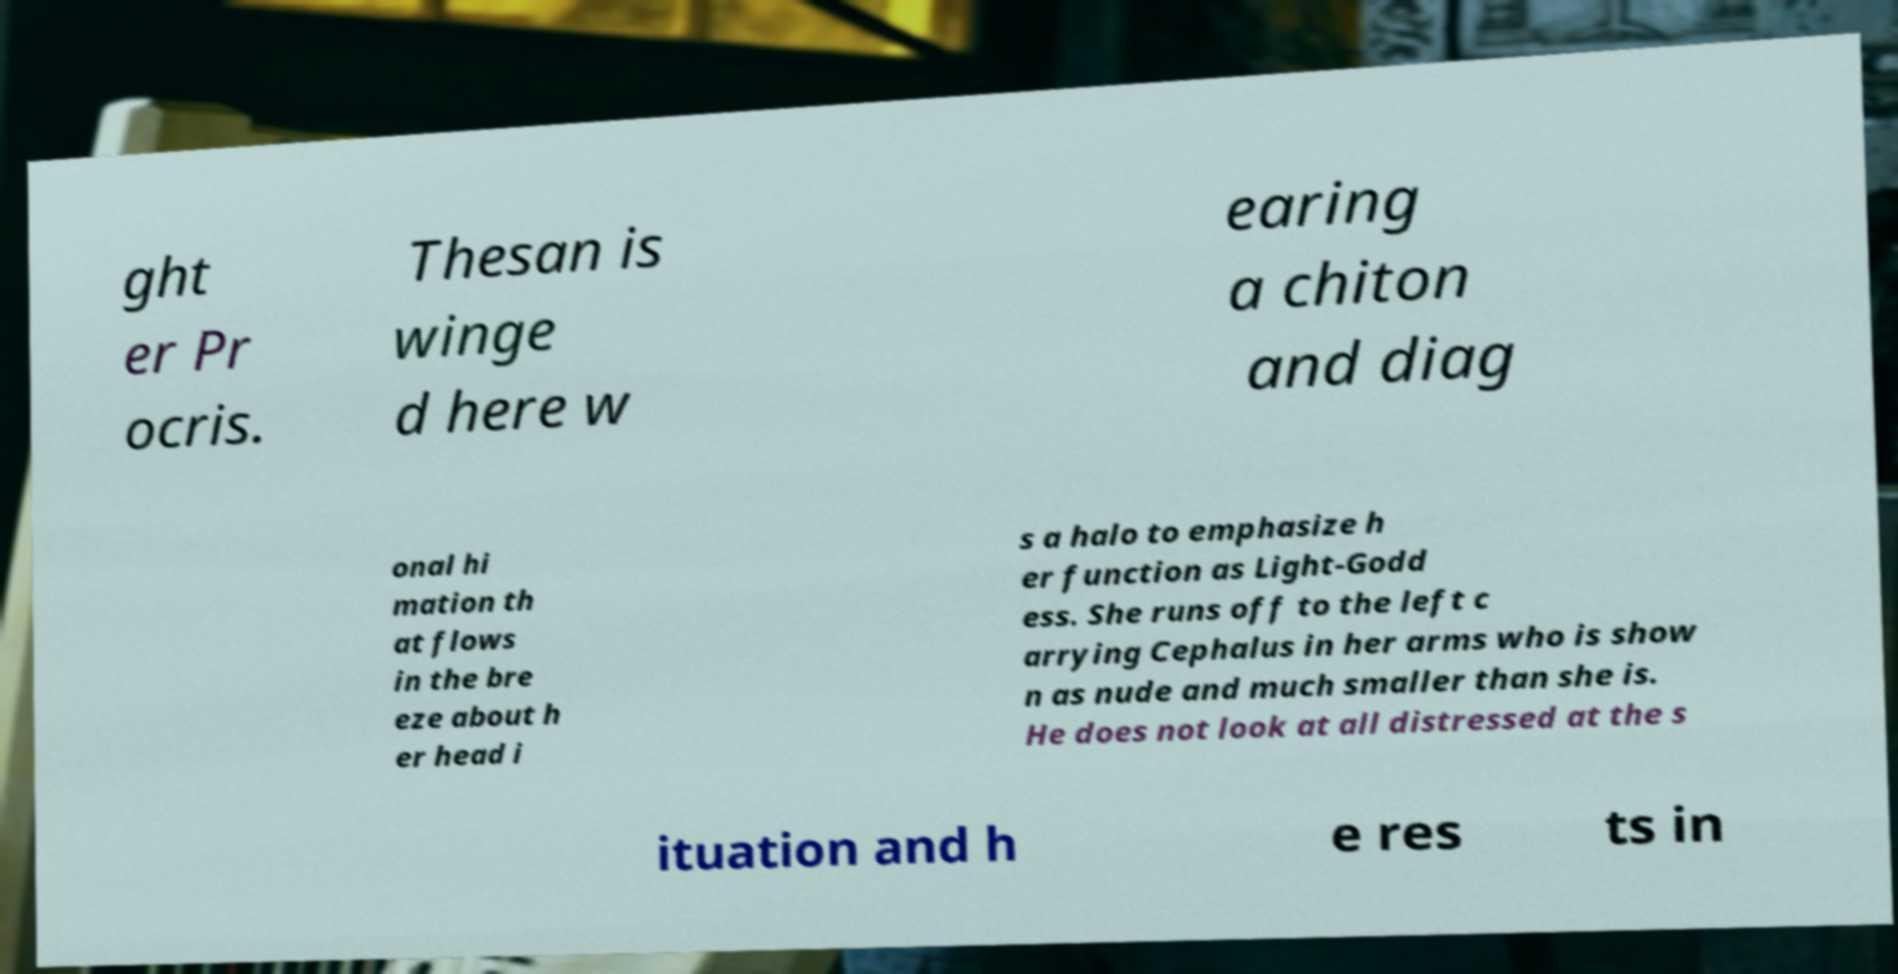Could you assist in decoding the text presented in this image and type it out clearly? ght er Pr ocris. Thesan is winge d here w earing a chiton and diag onal hi mation th at flows in the bre eze about h er head i s a halo to emphasize h er function as Light-Godd ess. She runs off to the left c arrying Cephalus in her arms who is show n as nude and much smaller than she is. He does not look at all distressed at the s ituation and h e res ts in 